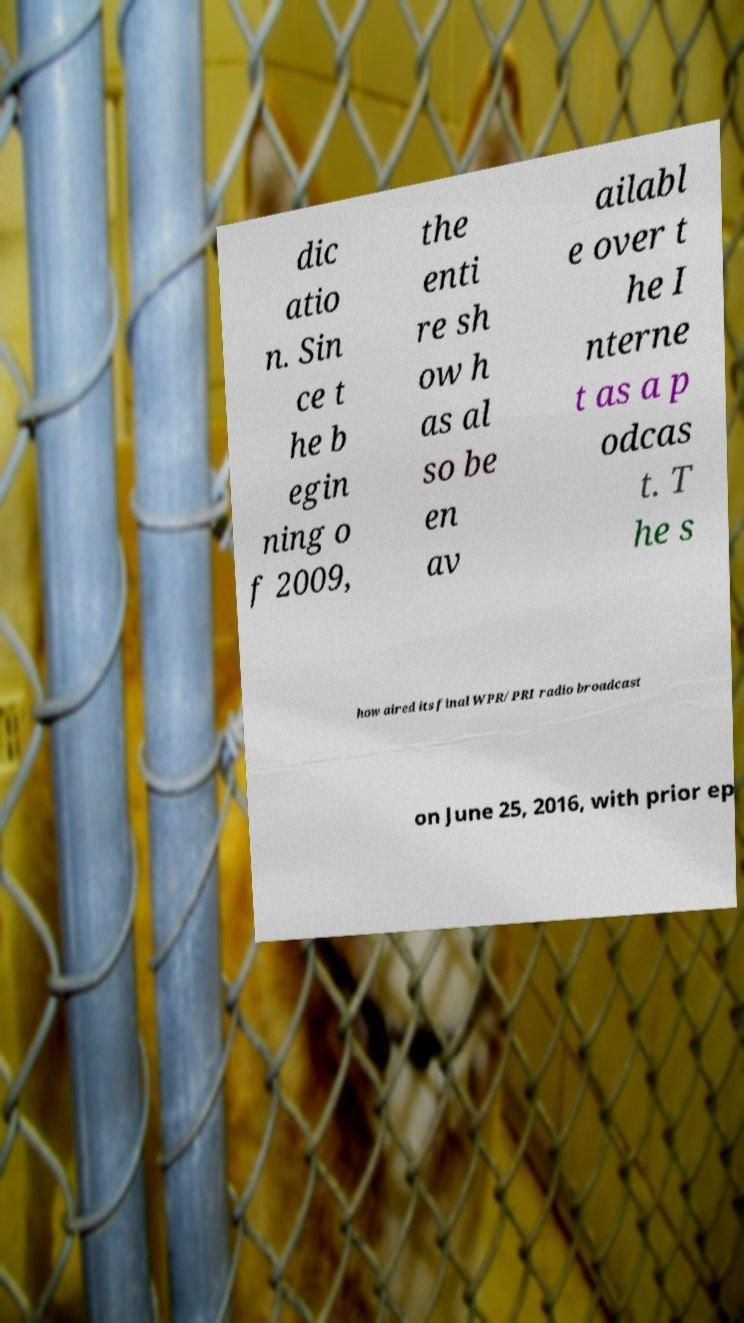Could you extract and type out the text from this image? dic atio n. Sin ce t he b egin ning o f 2009, the enti re sh ow h as al so be en av ailabl e over t he I nterne t as a p odcas t. T he s how aired its final WPR/PRI radio broadcast on June 25, 2016, with prior ep 